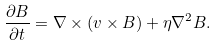<formula> <loc_0><loc_0><loc_500><loc_500>\frac { \partial { B } } { \partial t } = \nabla \times \left ( { v } \times { B } \right ) + \eta \nabla ^ { 2 } { B } .</formula> 